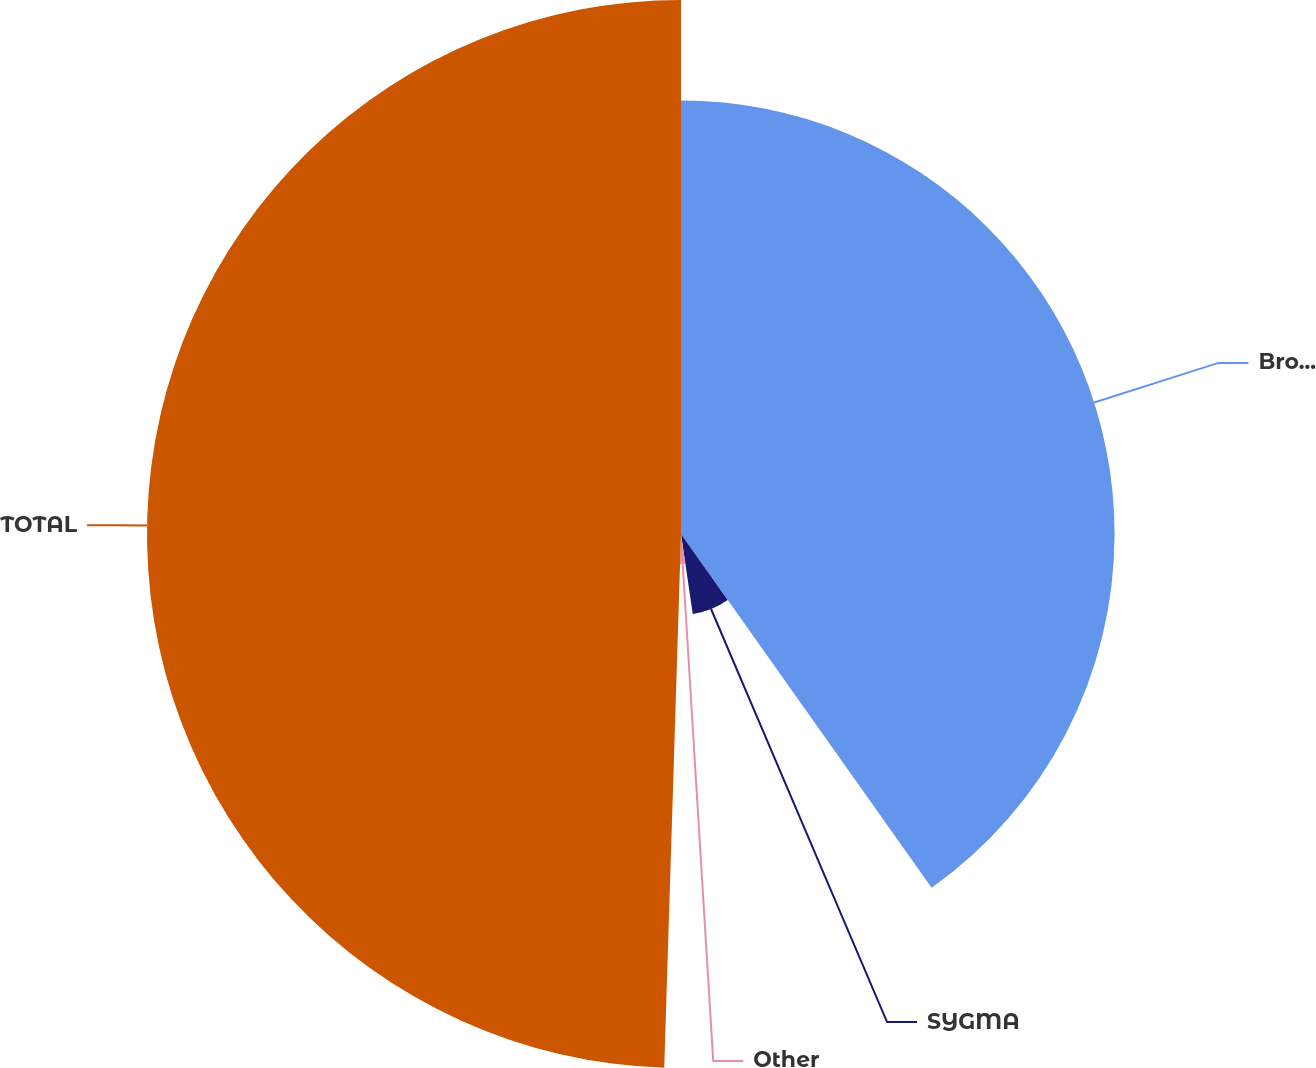Convert chart to OTSL. <chart><loc_0><loc_0><loc_500><loc_500><pie_chart><fcel>Broadline<fcel>SYGMA<fcel>Other<fcel>TOTAL<nl><fcel>40.19%<fcel>7.49%<fcel>2.82%<fcel>49.5%<nl></chart> 